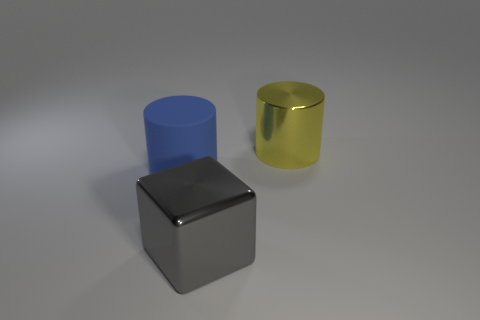Is there a yellow thing that has the same size as the yellow cylinder?
Offer a terse response. No. There is a cylinder to the left of the yellow cylinder; is its color the same as the metal thing on the left side of the yellow metallic thing?
Your answer should be compact. No. How many matte objects are tiny yellow cubes or large blue cylinders?
Give a very brief answer. 1. There is a large metal object that is in front of the metallic thing behind the large gray cube; how many large blue things are in front of it?
Keep it short and to the point. 0. What is the size of the thing that is the same material as the gray block?
Provide a succinct answer. Large. How many metallic blocks are the same color as the large matte cylinder?
Provide a short and direct response. 0. There is a cylinder that is to the left of the yellow thing; is its size the same as the shiny cylinder?
Ensure brevity in your answer.  Yes. What is the color of the large thing that is both behind the cube and to the right of the big rubber cylinder?
Provide a succinct answer. Yellow. What number of things are either gray metallic cubes or big metal things behind the big gray metal object?
Offer a very short reply. 2. The thing behind the cylinder to the left of the big shiny object in front of the blue rubber object is made of what material?
Provide a short and direct response. Metal. 